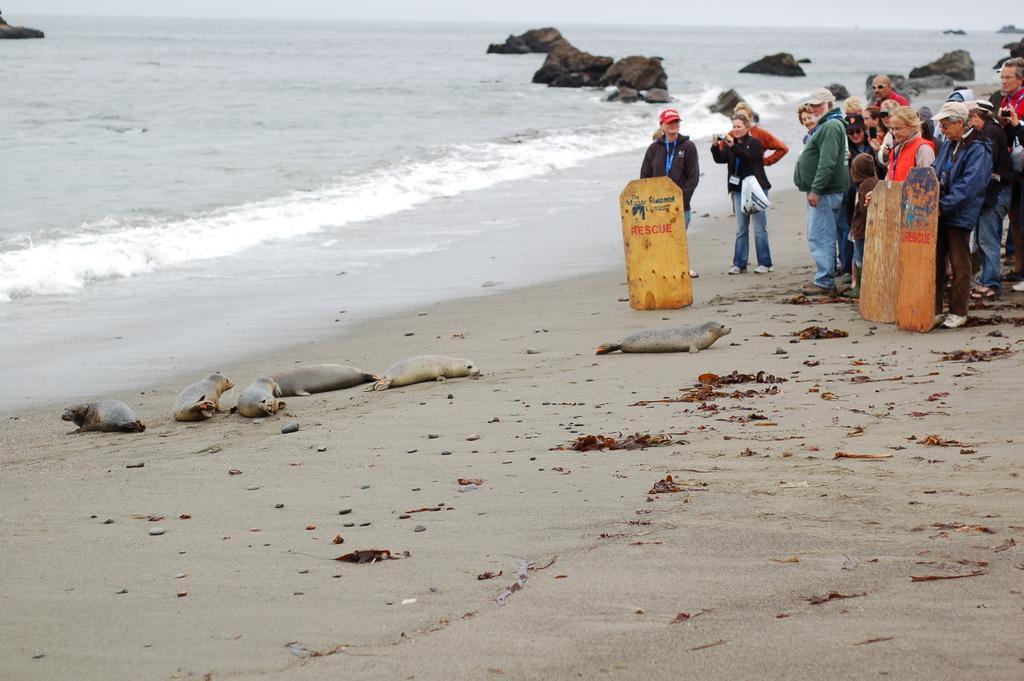Can you describe this image briefly? There are few Harbor seals on the sand and there are few people standing in the right corner and there is water in the background. 